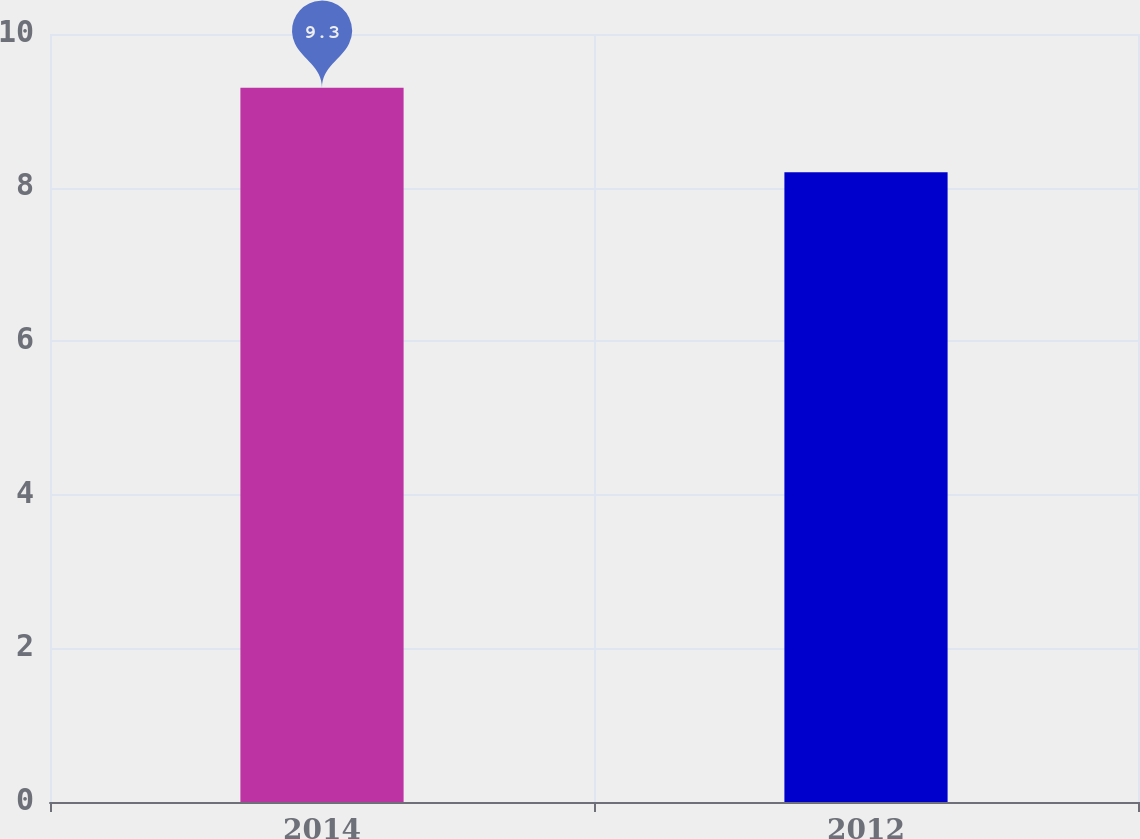Convert chart to OTSL. <chart><loc_0><loc_0><loc_500><loc_500><bar_chart><fcel>2014<fcel>2012<nl><fcel>9.3<fcel>8.2<nl></chart> 